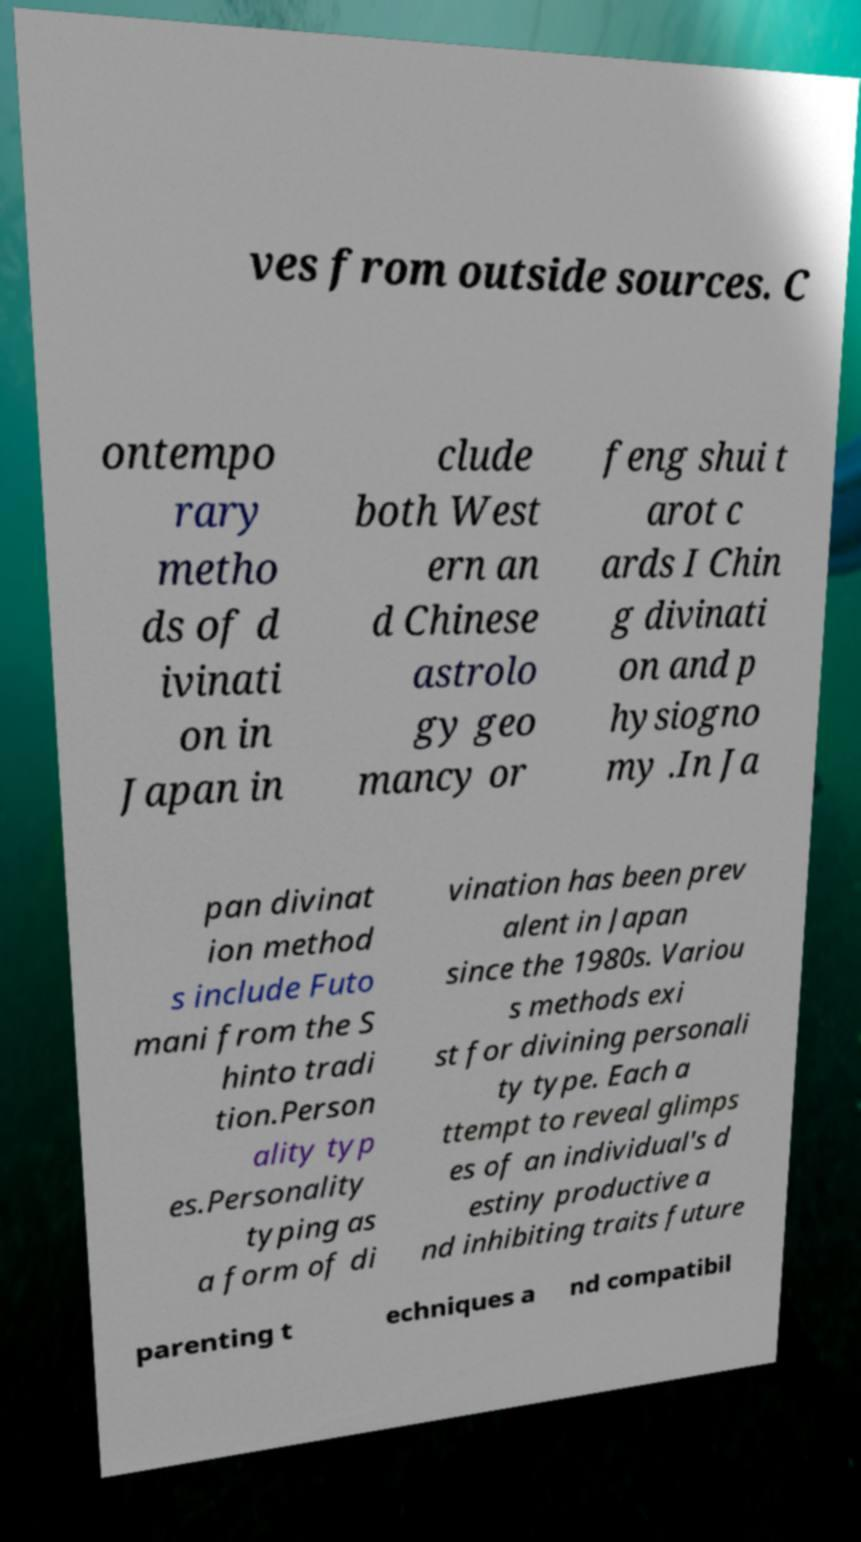Please read and relay the text visible in this image. What does it say? ves from outside sources. C ontempo rary metho ds of d ivinati on in Japan in clude both West ern an d Chinese astrolo gy geo mancy or feng shui t arot c ards I Chin g divinati on and p hysiogno my .In Ja pan divinat ion method s include Futo mani from the S hinto tradi tion.Person ality typ es.Personality typing as a form of di vination has been prev alent in Japan since the 1980s. Variou s methods exi st for divining personali ty type. Each a ttempt to reveal glimps es of an individual's d estiny productive a nd inhibiting traits future parenting t echniques a nd compatibil 